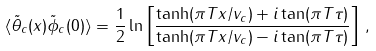<formula> <loc_0><loc_0><loc_500><loc_500>\langle \tilde { \theta } _ { c } ( x ) \tilde { \phi } _ { c } ( 0 ) \rangle = \frac { 1 } { 2 } \ln \left [ \frac { \tanh ( \pi T x / v _ { c } ) + i \tan ( \pi T \tau ) } { \tanh ( \pi T x / v _ { c } ) - i \tan ( \pi T \tau ) } \right ] \, ,</formula> 